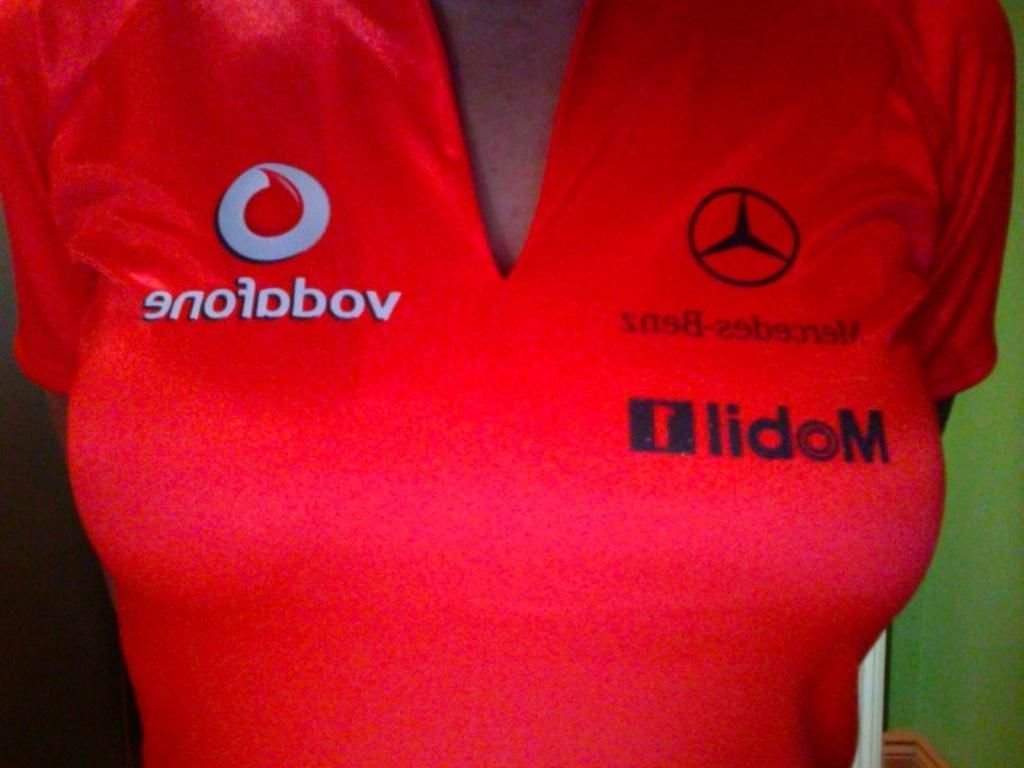Who is present in the image? There is a woman in the image. What is the woman wearing? The woman is wearing a red dress. What type of hose is the woman using to water the plants in the image? There is no hose or plants present in the image; it only features a woman wearing a red dress. 